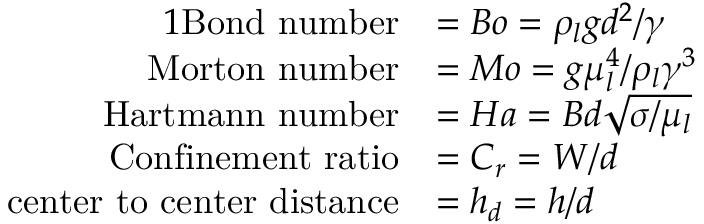<formula> <loc_0><loc_0><loc_500><loc_500>\begin{array} { r l } { { 1 } B o n d n u m b e r } & { = B o = \rho _ { l } g d ^ { 2 } / \gamma } \\ { M o r t o n n u m b e r } & { = M o = g \mu _ { l } ^ { 4 } / \rho _ { l } \gamma ^ { 3 } } \\ { H a r t m a n n n u m b e r } & { = H a = B d \sqrt { \sigma / \mu _ { l } } } \\ { C o n f i n e m e n t r a t i o } & { = C _ { r } = W / d } \\ { c e n t e r t o c e n t e r d i s t a n c e } & { = h _ { d } = h / d } \end{array}</formula> 